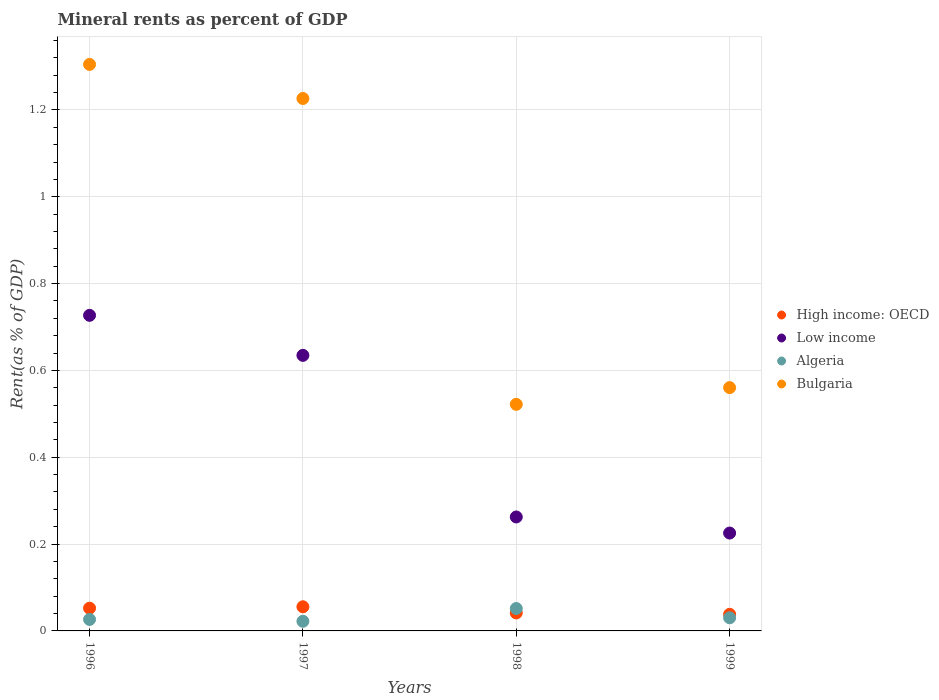What is the mineral rent in Algeria in 1999?
Give a very brief answer. 0.03. Across all years, what is the maximum mineral rent in Algeria?
Keep it short and to the point. 0.05. Across all years, what is the minimum mineral rent in High income: OECD?
Keep it short and to the point. 0.04. What is the total mineral rent in Algeria in the graph?
Provide a short and direct response. 0.13. What is the difference between the mineral rent in Algeria in 1997 and that in 1998?
Your answer should be very brief. -0.03. What is the difference between the mineral rent in High income: OECD in 1998 and the mineral rent in Low income in 1997?
Provide a succinct answer. -0.59. What is the average mineral rent in High income: OECD per year?
Keep it short and to the point. 0.05. In the year 1997, what is the difference between the mineral rent in High income: OECD and mineral rent in Low income?
Your answer should be compact. -0.58. In how many years, is the mineral rent in Bulgaria greater than 1.08 %?
Offer a terse response. 2. What is the ratio of the mineral rent in High income: OECD in 1997 to that in 1999?
Keep it short and to the point. 1.45. Is the difference between the mineral rent in High income: OECD in 1997 and 1999 greater than the difference between the mineral rent in Low income in 1997 and 1999?
Offer a very short reply. No. What is the difference between the highest and the second highest mineral rent in Bulgaria?
Your answer should be very brief. 0.08. What is the difference between the highest and the lowest mineral rent in Algeria?
Make the answer very short. 0.03. Is the sum of the mineral rent in Low income in 1998 and 1999 greater than the maximum mineral rent in Algeria across all years?
Make the answer very short. Yes. Is it the case that in every year, the sum of the mineral rent in Bulgaria and mineral rent in High income: OECD  is greater than the sum of mineral rent in Low income and mineral rent in Algeria?
Keep it short and to the point. No. Is it the case that in every year, the sum of the mineral rent in Algeria and mineral rent in Bulgaria  is greater than the mineral rent in Low income?
Your response must be concise. Yes. Is the mineral rent in Low income strictly greater than the mineral rent in Algeria over the years?
Provide a succinct answer. Yes. Is the mineral rent in Algeria strictly less than the mineral rent in Low income over the years?
Keep it short and to the point. Yes. How many dotlines are there?
Your answer should be very brief. 4. What is the difference between two consecutive major ticks on the Y-axis?
Provide a succinct answer. 0.2. Does the graph contain any zero values?
Offer a very short reply. No. Does the graph contain grids?
Provide a succinct answer. Yes. How many legend labels are there?
Make the answer very short. 4. How are the legend labels stacked?
Ensure brevity in your answer.  Vertical. What is the title of the graph?
Provide a short and direct response. Mineral rents as percent of GDP. Does "Portugal" appear as one of the legend labels in the graph?
Your response must be concise. No. What is the label or title of the Y-axis?
Your answer should be very brief. Rent(as % of GDP). What is the Rent(as % of GDP) of High income: OECD in 1996?
Your answer should be very brief. 0.05. What is the Rent(as % of GDP) in Low income in 1996?
Provide a short and direct response. 0.73. What is the Rent(as % of GDP) in Algeria in 1996?
Make the answer very short. 0.03. What is the Rent(as % of GDP) in Bulgaria in 1996?
Keep it short and to the point. 1.3. What is the Rent(as % of GDP) of High income: OECD in 1997?
Provide a succinct answer. 0.06. What is the Rent(as % of GDP) of Low income in 1997?
Give a very brief answer. 0.63. What is the Rent(as % of GDP) of Algeria in 1997?
Your answer should be compact. 0.02. What is the Rent(as % of GDP) of Bulgaria in 1997?
Provide a short and direct response. 1.23. What is the Rent(as % of GDP) of High income: OECD in 1998?
Ensure brevity in your answer.  0.04. What is the Rent(as % of GDP) of Low income in 1998?
Your response must be concise. 0.26. What is the Rent(as % of GDP) of Algeria in 1998?
Your response must be concise. 0.05. What is the Rent(as % of GDP) in Bulgaria in 1998?
Provide a short and direct response. 0.52. What is the Rent(as % of GDP) in High income: OECD in 1999?
Offer a very short reply. 0.04. What is the Rent(as % of GDP) in Low income in 1999?
Your answer should be very brief. 0.23. What is the Rent(as % of GDP) of Algeria in 1999?
Make the answer very short. 0.03. What is the Rent(as % of GDP) in Bulgaria in 1999?
Offer a terse response. 0.56. Across all years, what is the maximum Rent(as % of GDP) in High income: OECD?
Give a very brief answer. 0.06. Across all years, what is the maximum Rent(as % of GDP) of Low income?
Keep it short and to the point. 0.73. Across all years, what is the maximum Rent(as % of GDP) of Algeria?
Ensure brevity in your answer.  0.05. Across all years, what is the maximum Rent(as % of GDP) of Bulgaria?
Give a very brief answer. 1.3. Across all years, what is the minimum Rent(as % of GDP) in High income: OECD?
Your answer should be compact. 0.04. Across all years, what is the minimum Rent(as % of GDP) of Low income?
Ensure brevity in your answer.  0.23. Across all years, what is the minimum Rent(as % of GDP) of Algeria?
Offer a very short reply. 0.02. Across all years, what is the minimum Rent(as % of GDP) of Bulgaria?
Provide a short and direct response. 0.52. What is the total Rent(as % of GDP) of High income: OECD in the graph?
Your answer should be very brief. 0.19. What is the total Rent(as % of GDP) of Low income in the graph?
Provide a succinct answer. 1.85. What is the total Rent(as % of GDP) in Algeria in the graph?
Your answer should be very brief. 0.13. What is the total Rent(as % of GDP) in Bulgaria in the graph?
Your answer should be very brief. 3.61. What is the difference between the Rent(as % of GDP) of High income: OECD in 1996 and that in 1997?
Your response must be concise. -0. What is the difference between the Rent(as % of GDP) in Low income in 1996 and that in 1997?
Provide a succinct answer. 0.09. What is the difference between the Rent(as % of GDP) in Algeria in 1996 and that in 1997?
Your response must be concise. 0. What is the difference between the Rent(as % of GDP) of Bulgaria in 1996 and that in 1997?
Give a very brief answer. 0.08. What is the difference between the Rent(as % of GDP) of High income: OECD in 1996 and that in 1998?
Make the answer very short. 0.01. What is the difference between the Rent(as % of GDP) in Low income in 1996 and that in 1998?
Offer a terse response. 0.46. What is the difference between the Rent(as % of GDP) in Algeria in 1996 and that in 1998?
Ensure brevity in your answer.  -0.03. What is the difference between the Rent(as % of GDP) in Bulgaria in 1996 and that in 1998?
Offer a terse response. 0.78. What is the difference between the Rent(as % of GDP) of High income: OECD in 1996 and that in 1999?
Give a very brief answer. 0.01. What is the difference between the Rent(as % of GDP) of Low income in 1996 and that in 1999?
Offer a very short reply. 0.5. What is the difference between the Rent(as % of GDP) of Algeria in 1996 and that in 1999?
Give a very brief answer. -0. What is the difference between the Rent(as % of GDP) of Bulgaria in 1996 and that in 1999?
Your answer should be compact. 0.74. What is the difference between the Rent(as % of GDP) of High income: OECD in 1997 and that in 1998?
Ensure brevity in your answer.  0.01. What is the difference between the Rent(as % of GDP) in Low income in 1997 and that in 1998?
Your response must be concise. 0.37. What is the difference between the Rent(as % of GDP) of Algeria in 1997 and that in 1998?
Provide a short and direct response. -0.03. What is the difference between the Rent(as % of GDP) of Bulgaria in 1997 and that in 1998?
Your answer should be very brief. 0.7. What is the difference between the Rent(as % of GDP) of High income: OECD in 1997 and that in 1999?
Your answer should be compact. 0.02. What is the difference between the Rent(as % of GDP) of Low income in 1997 and that in 1999?
Offer a terse response. 0.41. What is the difference between the Rent(as % of GDP) of Algeria in 1997 and that in 1999?
Provide a succinct answer. -0.01. What is the difference between the Rent(as % of GDP) of Bulgaria in 1997 and that in 1999?
Offer a very short reply. 0.67. What is the difference between the Rent(as % of GDP) in High income: OECD in 1998 and that in 1999?
Keep it short and to the point. 0. What is the difference between the Rent(as % of GDP) in Low income in 1998 and that in 1999?
Ensure brevity in your answer.  0.04. What is the difference between the Rent(as % of GDP) of Algeria in 1998 and that in 1999?
Make the answer very short. 0.02. What is the difference between the Rent(as % of GDP) in Bulgaria in 1998 and that in 1999?
Make the answer very short. -0.04. What is the difference between the Rent(as % of GDP) of High income: OECD in 1996 and the Rent(as % of GDP) of Low income in 1997?
Your response must be concise. -0.58. What is the difference between the Rent(as % of GDP) of High income: OECD in 1996 and the Rent(as % of GDP) of Algeria in 1997?
Give a very brief answer. 0.03. What is the difference between the Rent(as % of GDP) in High income: OECD in 1996 and the Rent(as % of GDP) in Bulgaria in 1997?
Provide a succinct answer. -1.17. What is the difference between the Rent(as % of GDP) in Low income in 1996 and the Rent(as % of GDP) in Algeria in 1997?
Provide a succinct answer. 0.7. What is the difference between the Rent(as % of GDP) of Low income in 1996 and the Rent(as % of GDP) of Bulgaria in 1997?
Offer a terse response. -0.5. What is the difference between the Rent(as % of GDP) in Algeria in 1996 and the Rent(as % of GDP) in Bulgaria in 1997?
Your answer should be very brief. -1.2. What is the difference between the Rent(as % of GDP) of High income: OECD in 1996 and the Rent(as % of GDP) of Low income in 1998?
Provide a short and direct response. -0.21. What is the difference between the Rent(as % of GDP) of High income: OECD in 1996 and the Rent(as % of GDP) of Algeria in 1998?
Make the answer very short. 0. What is the difference between the Rent(as % of GDP) in High income: OECD in 1996 and the Rent(as % of GDP) in Bulgaria in 1998?
Give a very brief answer. -0.47. What is the difference between the Rent(as % of GDP) of Low income in 1996 and the Rent(as % of GDP) of Algeria in 1998?
Offer a very short reply. 0.68. What is the difference between the Rent(as % of GDP) in Low income in 1996 and the Rent(as % of GDP) in Bulgaria in 1998?
Ensure brevity in your answer.  0.2. What is the difference between the Rent(as % of GDP) in Algeria in 1996 and the Rent(as % of GDP) in Bulgaria in 1998?
Offer a terse response. -0.5. What is the difference between the Rent(as % of GDP) of High income: OECD in 1996 and the Rent(as % of GDP) of Low income in 1999?
Give a very brief answer. -0.17. What is the difference between the Rent(as % of GDP) of High income: OECD in 1996 and the Rent(as % of GDP) of Algeria in 1999?
Give a very brief answer. 0.02. What is the difference between the Rent(as % of GDP) of High income: OECD in 1996 and the Rent(as % of GDP) of Bulgaria in 1999?
Offer a very short reply. -0.51. What is the difference between the Rent(as % of GDP) in Low income in 1996 and the Rent(as % of GDP) in Algeria in 1999?
Give a very brief answer. 0.7. What is the difference between the Rent(as % of GDP) of Low income in 1996 and the Rent(as % of GDP) of Bulgaria in 1999?
Provide a succinct answer. 0.17. What is the difference between the Rent(as % of GDP) of Algeria in 1996 and the Rent(as % of GDP) of Bulgaria in 1999?
Ensure brevity in your answer.  -0.53. What is the difference between the Rent(as % of GDP) in High income: OECD in 1997 and the Rent(as % of GDP) in Low income in 1998?
Offer a very short reply. -0.21. What is the difference between the Rent(as % of GDP) of High income: OECD in 1997 and the Rent(as % of GDP) of Algeria in 1998?
Provide a short and direct response. 0. What is the difference between the Rent(as % of GDP) in High income: OECD in 1997 and the Rent(as % of GDP) in Bulgaria in 1998?
Make the answer very short. -0.47. What is the difference between the Rent(as % of GDP) in Low income in 1997 and the Rent(as % of GDP) in Algeria in 1998?
Keep it short and to the point. 0.58. What is the difference between the Rent(as % of GDP) of Low income in 1997 and the Rent(as % of GDP) of Bulgaria in 1998?
Provide a short and direct response. 0.11. What is the difference between the Rent(as % of GDP) in Algeria in 1997 and the Rent(as % of GDP) in Bulgaria in 1998?
Ensure brevity in your answer.  -0.5. What is the difference between the Rent(as % of GDP) in High income: OECD in 1997 and the Rent(as % of GDP) in Low income in 1999?
Your answer should be compact. -0.17. What is the difference between the Rent(as % of GDP) of High income: OECD in 1997 and the Rent(as % of GDP) of Algeria in 1999?
Provide a short and direct response. 0.03. What is the difference between the Rent(as % of GDP) of High income: OECD in 1997 and the Rent(as % of GDP) of Bulgaria in 1999?
Your response must be concise. -0.5. What is the difference between the Rent(as % of GDP) of Low income in 1997 and the Rent(as % of GDP) of Algeria in 1999?
Provide a short and direct response. 0.6. What is the difference between the Rent(as % of GDP) in Low income in 1997 and the Rent(as % of GDP) in Bulgaria in 1999?
Provide a short and direct response. 0.07. What is the difference between the Rent(as % of GDP) of Algeria in 1997 and the Rent(as % of GDP) of Bulgaria in 1999?
Make the answer very short. -0.54. What is the difference between the Rent(as % of GDP) of High income: OECD in 1998 and the Rent(as % of GDP) of Low income in 1999?
Offer a very short reply. -0.18. What is the difference between the Rent(as % of GDP) of High income: OECD in 1998 and the Rent(as % of GDP) of Algeria in 1999?
Your answer should be compact. 0.01. What is the difference between the Rent(as % of GDP) of High income: OECD in 1998 and the Rent(as % of GDP) of Bulgaria in 1999?
Provide a short and direct response. -0.52. What is the difference between the Rent(as % of GDP) in Low income in 1998 and the Rent(as % of GDP) in Algeria in 1999?
Offer a very short reply. 0.23. What is the difference between the Rent(as % of GDP) of Low income in 1998 and the Rent(as % of GDP) of Bulgaria in 1999?
Make the answer very short. -0.3. What is the difference between the Rent(as % of GDP) in Algeria in 1998 and the Rent(as % of GDP) in Bulgaria in 1999?
Make the answer very short. -0.51. What is the average Rent(as % of GDP) in High income: OECD per year?
Your answer should be very brief. 0.05. What is the average Rent(as % of GDP) in Low income per year?
Make the answer very short. 0.46. What is the average Rent(as % of GDP) of Algeria per year?
Provide a succinct answer. 0.03. What is the average Rent(as % of GDP) in Bulgaria per year?
Keep it short and to the point. 0.9. In the year 1996, what is the difference between the Rent(as % of GDP) of High income: OECD and Rent(as % of GDP) of Low income?
Keep it short and to the point. -0.67. In the year 1996, what is the difference between the Rent(as % of GDP) of High income: OECD and Rent(as % of GDP) of Algeria?
Offer a terse response. 0.03. In the year 1996, what is the difference between the Rent(as % of GDP) in High income: OECD and Rent(as % of GDP) in Bulgaria?
Give a very brief answer. -1.25. In the year 1996, what is the difference between the Rent(as % of GDP) of Low income and Rent(as % of GDP) of Algeria?
Your answer should be very brief. 0.7. In the year 1996, what is the difference between the Rent(as % of GDP) of Low income and Rent(as % of GDP) of Bulgaria?
Your response must be concise. -0.58. In the year 1996, what is the difference between the Rent(as % of GDP) of Algeria and Rent(as % of GDP) of Bulgaria?
Offer a terse response. -1.28. In the year 1997, what is the difference between the Rent(as % of GDP) in High income: OECD and Rent(as % of GDP) in Low income?
Ensure brevity in your answer.  -0.58. In the year 1997, what is the difference between the Rent(as % of GDP) in High income: OECD and Rent(as % of GDP) in Algeria?
Make the answer very short. 0.03. In the year 1997, what is the difference between the Rent(as % of GDP) of High income: OECD and Rent(as % of GDP) of Bulgaria?
Provide a short and direct response. -1.17. In the year 1997, what is the difference between the Rent(as % of GDP) of Low income and Rent(as % of GDP) of Algeria?
Keep it short and to the point. 0.61. In the year 1997, what is the difference between the Rent(as % of GDP) in Low income and Rent(as % of GDP) in Bulgaria?
Make the answer very short. -0.59. In the year 1997, what is the difference between the Rent(as % of GDP) in Algeria and Rent(as % of GDP) in Bulgaria?
Ensure brevity in your answer.  -1.2. In the year 1998, what is the difference between the Rent(as % of GDP) in High income: OECD and Rent(as % of GDP) in Low income?
Your response must be concise. -0.22. In the year 1998, what is the difference between the Rent(as % of GDP) in High income: OECD and Rent(as % of GDP) in Algeria?
Give a very brief answer. -0.01. In the year 1998, what is the difference between the Rent(as % of GDP) in High income: OECD and Rent(as % of GDP) in Bulgaria?
Give a very brief answer. -0.48. In the year 1998, what is the difference between the Rent(as % of GDP) of Low income and Rent(as % of GDP) of Algeria?
Provide a short and direct response. 0.21. In the year 1998, what is the difference between the Rent(as % of GDP) in Low income and Rent(as % of GDP) in Bulgaria?
Make the answer very short. -0.26. In the year 1998, what is the difference between the Rent(as % of GDP) of Algeria and Rent(as % of GDP) of Bulgaria?
Your answer should be compact. -0.47. In the year 1999, what is the difference between the Rent(as % of GDP) of High income: OECD and Rent(as % of GDP) of Low income?
Your response must be concise. -0.19. In the year 1999, what is the difference between the Rent(as % of GDP) in High income: OECD and Rent(as % of GDP) in Algeria?
Keep it short and to the point. 0.01. In the year 1999, what is the difference between the Rent(as % of GDP) in High income: OECD and Rent(as % of GDP) in Bulgaria?
Keep it short and to the point. -0.52. In the year 1999, what is the difference between the Rent(as % of GDP) of Low income and Rent(as % of GDP) of Algeria?
Your answer should be very brief. 0.2. In the year 1999, what is the difference between the Rent(as % of GDP) of Low income and Rent(as % of GDP) of Bulgaria?
Ensure brevity in your answer.  -0.33. In the year 1999, what is the difference between the Rent(as % of GDP) of Algeria and Rent(as % of GDP) of Bulgaria?
Provide a succinct answer. -0.53. What is the ratio of the Rent(as % of GDP) of High income: OECD in 1996 to that in 1997?
Make the answer very short. 0.94. What is the ratio of the Rent(as % of GDP) in Low income in 1996 to that in 1997?
Provide a succinct answer. 1.15. What is the ratio of the Rent(as % of GDP) of Algeria in 1996 to that in 1997?
Make the answer very short. 1.19. What is the ratio of the Rent(as % of GDP) in Bulgaria in 1996 to that in 1997?
Keep it short and to the point. 1.06. What is the ratio of the Rent(as % of GDP) of High income: OECD in 1996 to that in 1998?
Make the answer very short. 1.26. What is the ratio of the Rent(as % of GDP) in Low income in 1996 to that in 1998?
Offer a very short reply. 2.77. What is the ratio of the Rent(as % of GDP) of Algeria in 1996 to that in 1998?
Offer a terse response. 0.51. What is the ratio of the Rent(as % of GDP) in Bulgaria in 1996 to that in 1998?
Offer a terse response. 2.5. What is the ratio of the Rent(as % of GDP) of High income: OECD in 1996 to that in 1999?
Ensure brevity in your answer.  1.37. What is the ratio of the Rent(as % of GDP) in Low income in 1996 to that in 1999?
Provide a succinct answer. 3.22. What is the ratio of the Rent(as % of GDP) of Algeria in 1996 to that in 1999?
Make the answer very short. 0.87. What is the ratio of the Rent(as % of GDP) of Bulgaria in 1996 to that in 1999?
Your response must be concise. 2.33. What is the ratio of the Rent(as % of GDP) in High income: OECD in 1997 to that in 1998?
Make the answer very short. 1.34. What is the ratio of the Rent(as % of GDP) of Low income in 1997 to that in 1998?
Provide a succinct answer. 2.42. What is the ratio of the Rent(as % of GDP) of Algeria in 1997 to that in 1998?
Ensure brevity in your answer.  0.43. What is the ratio of the Rent(as % of GDP) in Bulgaria in 1997 to that in 1998?
Your answer should be very brief. 2.35. What is the ratio of the Rent(as % of GDP) of High income: OECD in 1997 to that in 1999?
Keep it short and to the point. 1.45. What is the ratio of the Rent(as % of GDP) of Low income in 1997 to that in 1999?
Ensure brevity in your answer.  2.82. What is the ratio of the Rent(as % of GDP) in Algeria in 1997 to that in 1999?
Your answer should be very brief. 0.73. What is the ratio of the Rent(as % of GDP) in Bulgaria in 1997 to that in 1999?
Make the answer very short. 2.19. What is the ratio of the Rent(as % of GDP) in High income: OECD in 1998 to that in 1999?
Offer a terse response. 1.08. What is the ratio of the Rent(as % of GDP) of Low income in 1998 to that in 1999?
Provide a succinct answer. 1.16. What is the ratio of the Rent(as % of GDP) of Algeria in 1998 to that in 1999?
Provide a succinct answer. 1.71. What is the ratio of the Rent(as % of GDP) of Bulgaria in 1998 to that in 1999?
Your response must be concise. 0.93. What is the difference between the highest and the second highest Rent(as % of GDP) in High income: OECD?
Your response must be concise. 0. What is the difference between the highest and the second highest Rent(as % of GDP) in Low income?
Keep it short and to the point. 0.09. What is the difference between the highest and the second highest Rent(as % of GDP) of Algeria?
Your answer should be compact. 0.02. What is the difference between the highest and the second highest Rent(as % of GDP) in Bulgaria?
Make the answer very short. 0.08. What is the difference between the highest and the lowest Rent(as % of GDP) of High income: OECD?
Provide a short and direct response. 0.02. What is the difference between the highest and the lowest Rent(as % of GDP) of Low income?
Give a very brief answer. 0.5. What is the difference between the highest and the lowest Rent(as % of GDP) in Algeria?
Your answer should be compact. 0.03. What is the difference between the highest and the lowest Rent(as % of GDP) in Bulgaria?
Give a very brief answer. 0.78. 